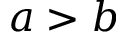Convert formula to latex. <formula><loc_0><loc_0><loc_500><loc_500>a > b</formula> 